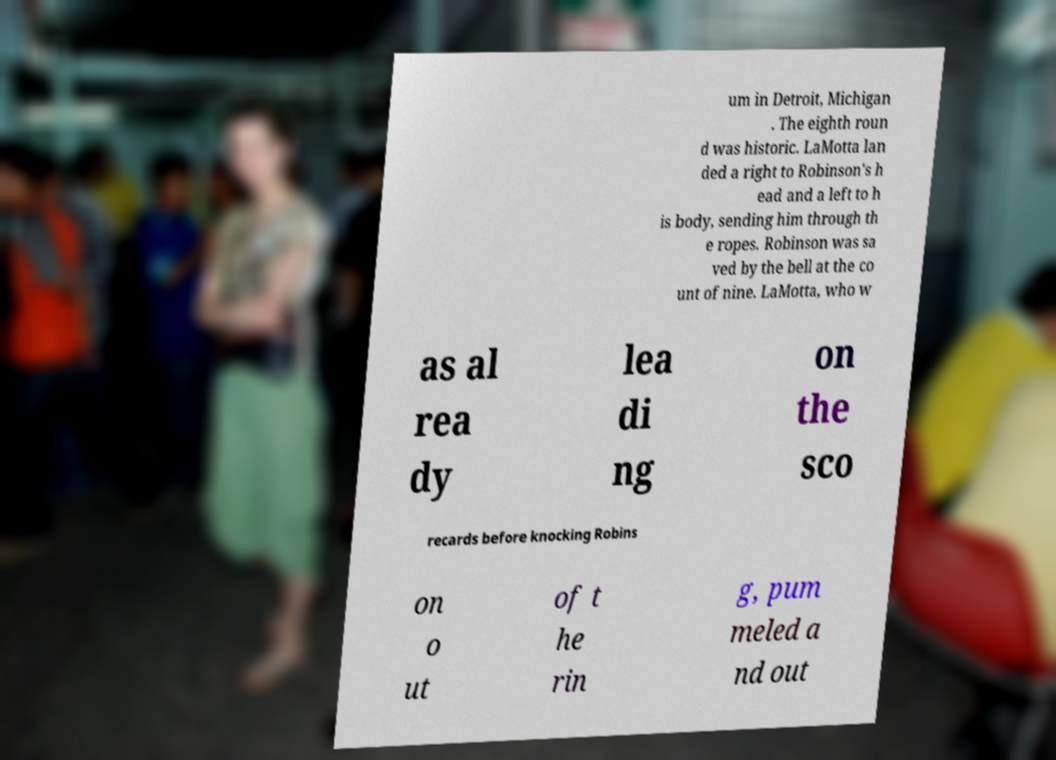For documentation purposes, I need the text within this image transcribed. Could you provide that? um in Detroit, Michigan . The eighth roun d was historic. LaMotta lan ded a right to Robinson's h ead and a left to h is body, sending him through th e ropes. Robinson was sa ved by the bell at the co unt of nine. LaMotta, who w as al rea dy lea di ng on the sco recards before knocking Robins on o ut of t he rin g, pum meled a nd out 